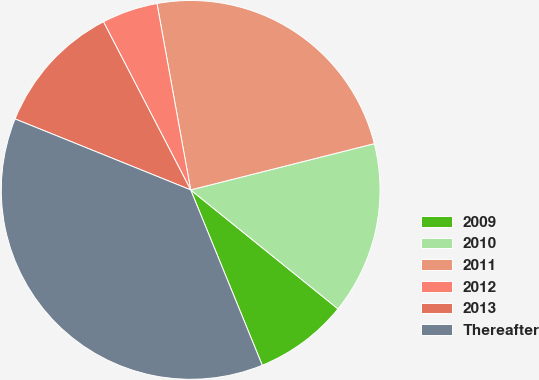Convert chart to OTSL. <chart><loc_0><loc_0><loc_500><loc_500><pie_chart><fcel>2009<fcel>2010<fcel>2011<fcel>2012<fcel>2013<fcel>Thereafter<nl><fcel>8.02%<fcel>14.74%<fcel>23.92%<fcel>4.77%<fcel>11.27%<fcel>37.28%<nl></chart> 